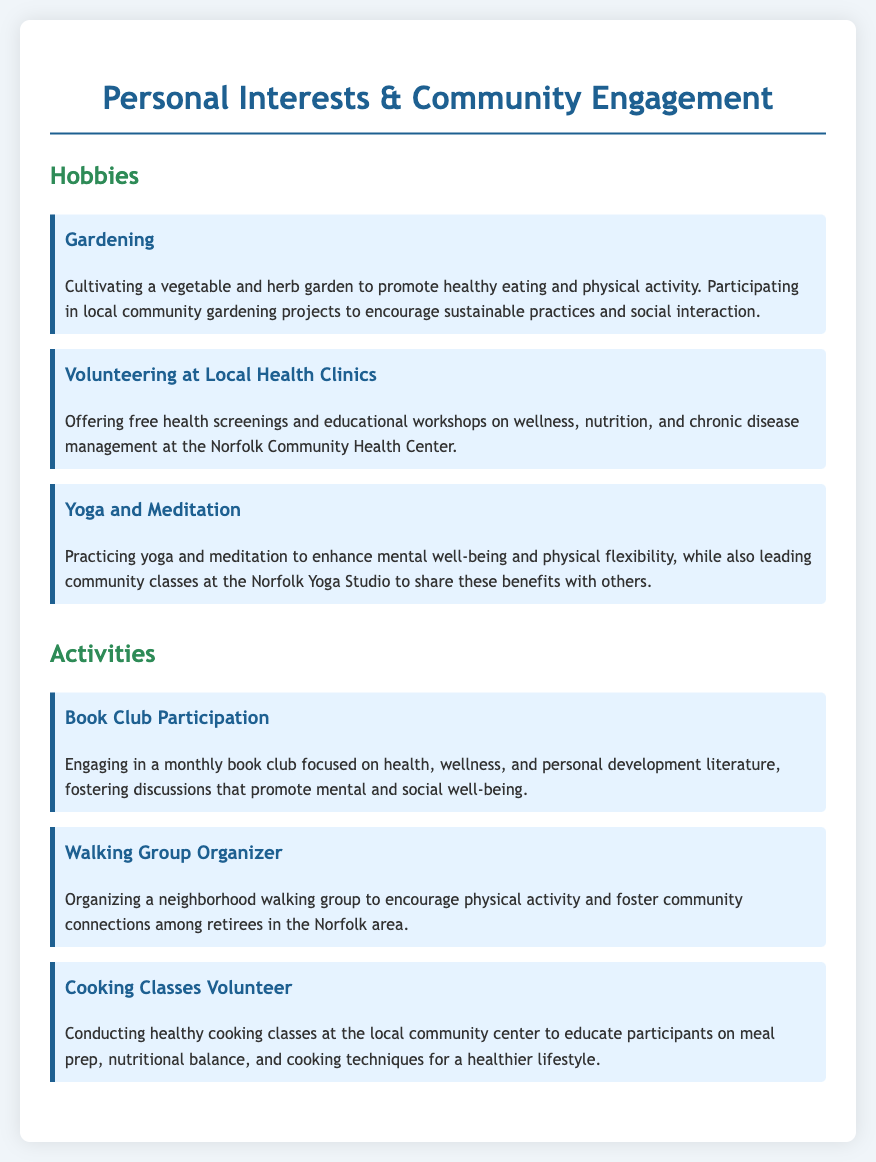What hobby involves promoting healthy eating? Gardening is mentioned as a hobby that promotes healthy eating by cultivating a vegetable and herb garden.
Answer: Gardening How does the volunteer work contribute to community wellness? Volunteering at local health clinics includes offering free health screenings and educational workshops, contributing to community wellness.
Answer: Free health screenings and educational workshops What activity focuses on personal development literature? The monthly book club is dedicated to health, wellness, and personal development literature.
Answer: Book Club Participation Who organizes a walking group? The document states that the neighborhood walking group is organized by the individual mentioned in the resume.
Answer: Walking Group Organizer What type of classes does the individual conduct at the community center? The individual conducts healthy cooking classes, educating participants on meal prep and nutritional balance.
Answer: Healthy cooking classes What practice is shared through leading community classes at the Norfolk Yoga Studio? The document states that yoga and meditation practices are shared by leading community classes.
Answer: Yoga and Meditation How do gardening projects foster social interaction? Community gardening projects encourage sustainable practices and social interaction among participants.
Answer: Sustainable practices and social interaction What is the focus of the yoga and meditation practice mentioned? The focus is on enhancing mental well-being and physical flexibility through yoga and meditation.
Answer: Mental well-being and physical flexibility 